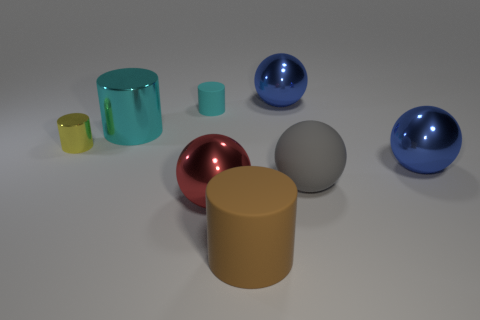What is the material of the brown object on the right side of the small shiny cylinder?
Offer a very short reply. Rubber. How many other objects are the same shape as the big gray thing?
Provide a short and direct response. 3. Do the tiny cyan rubber thing and the red metallic thing have the same shape?
Keep it short and to the point. No. Are there any metallic things behind the large red object?
Your response must be concise. Yes. What number of things are big blue objects or gray balls?
Your response must be concise. 3. How many other things are there of the same size as the red shiny sphere?
Your answer should be very brief. 5. What number of metallic spheres are both to the left of the big brown object and behind the yellow object?
Offer a very short reply. 0. There is a blue sphere behind the small cyan cylinder; is it the same size as the blue ball in front of the tiny cyan cylinder?
Ensure brevity in your answer.  Yes. What is the size of the cyan thing in front of the small rubber cylinder?
Your answer should be compact. Large. How many objects are cylinders that are on the left side of the small cyan matte cylinder or objects that are in front of the cyan rubber object?
Make the answer very short. 6. 